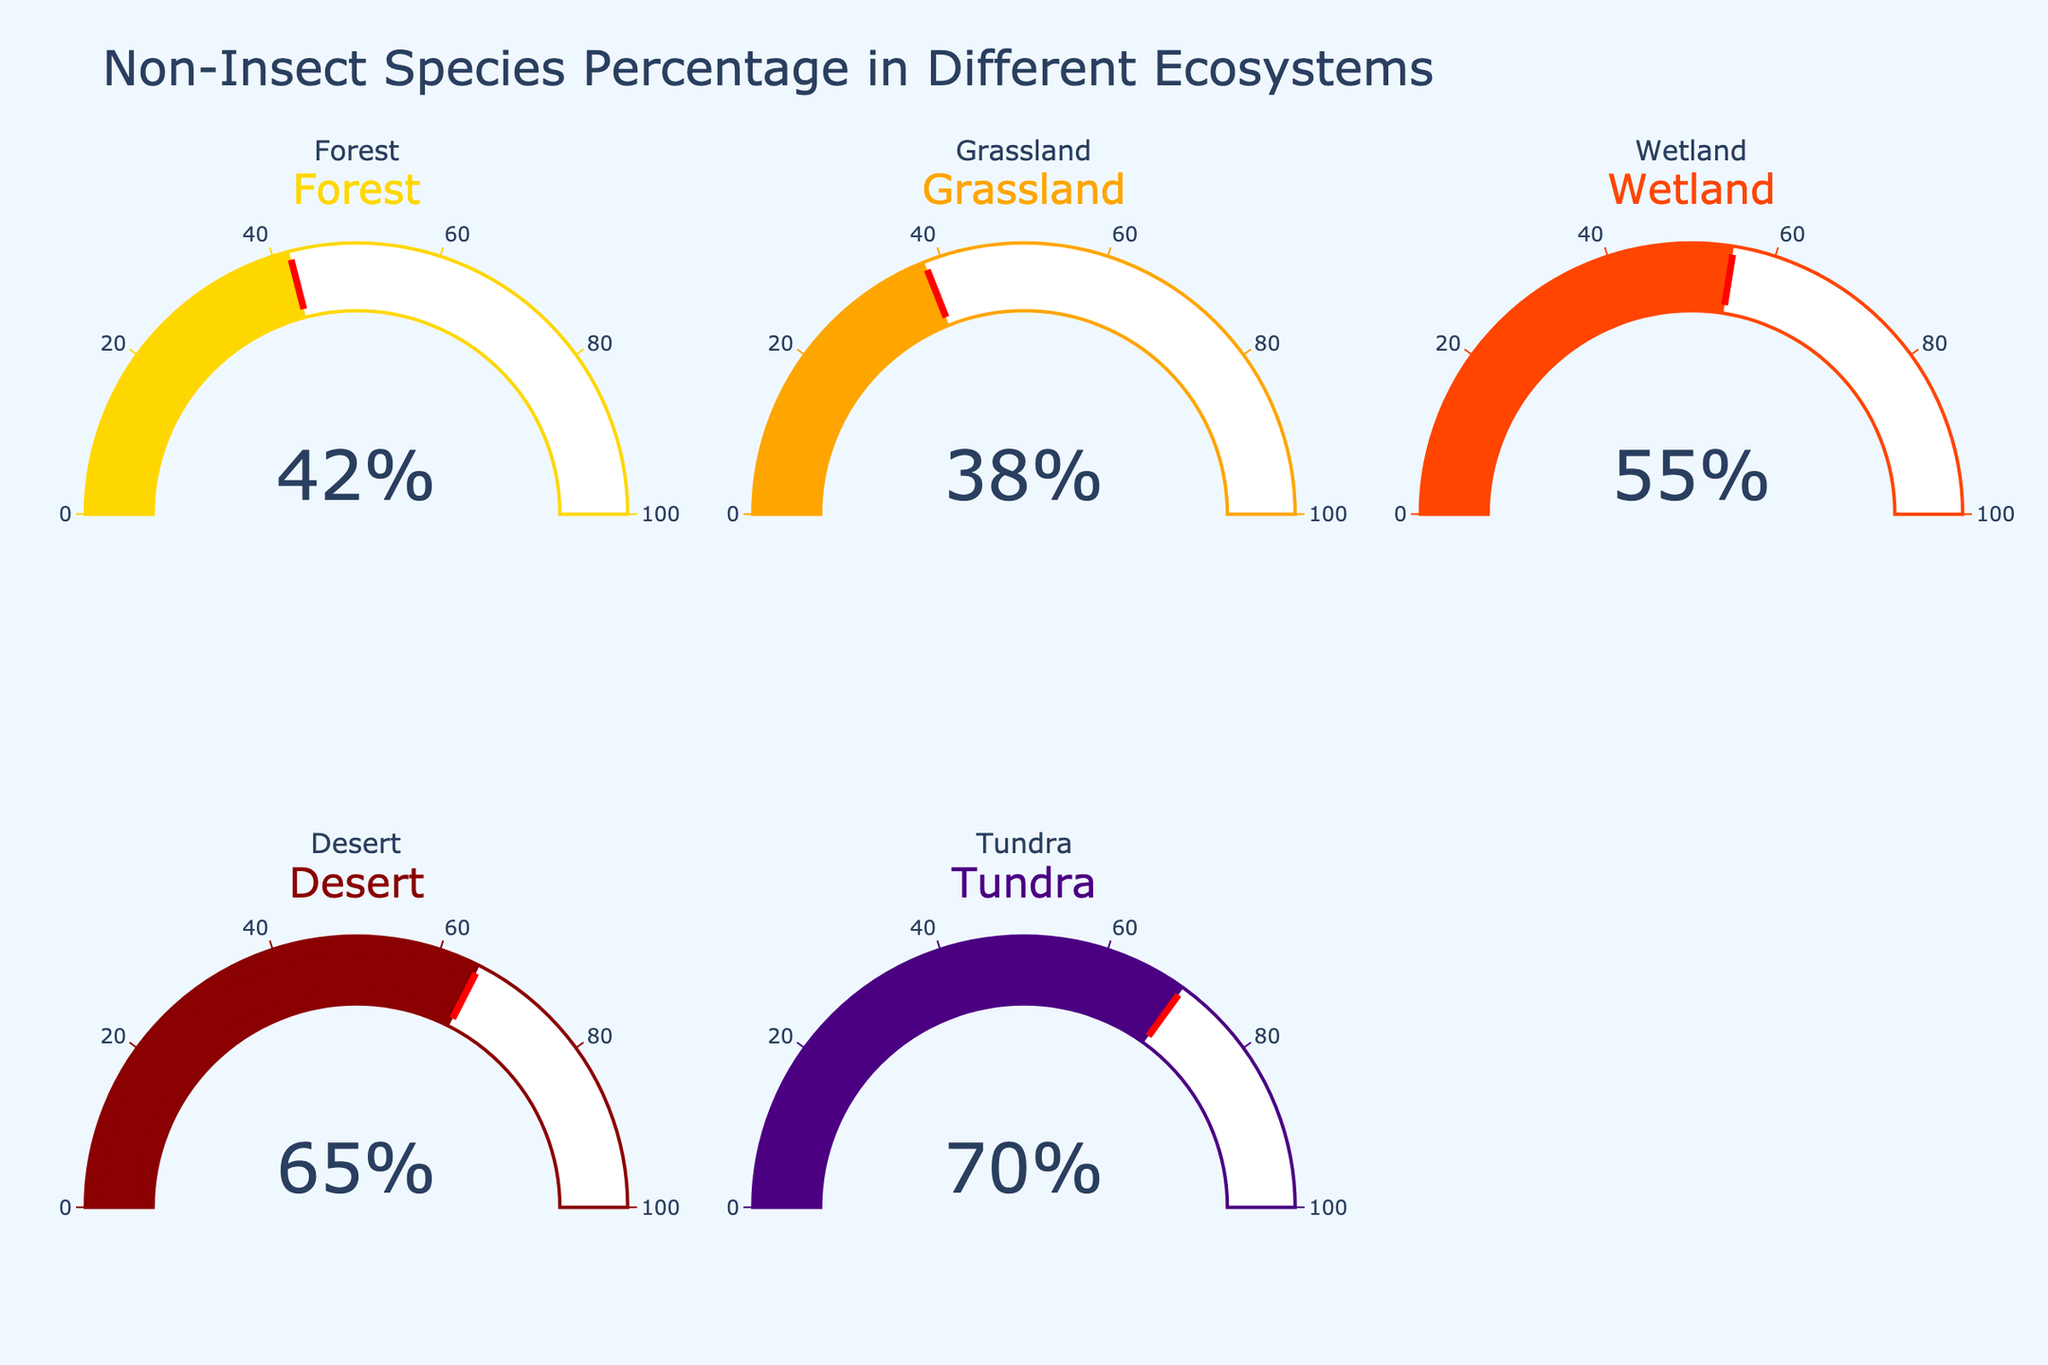Which ecosystem has the highest percentage of non-insect species? Look at the gauge chart values and identify the ecosystem with the highest percentage. The "Tundra" has 70%, which is the highest among all ecosystems.
Answer: Tundra What is the percentage of non-insect species in the Grassland ecosystem? Identify the gauge chart labeled "Grassland" and read the percentage value, which indicates 38%.
Answer: 38% How many ecosystems are displayed in total in the figure? Count all the gauge charts displayed in the figure while noting that there are 5 ecosystems represented (Forest, Grassland, Wetland, Desert, and Tundra).
Answer: 5 Which ecosystem has a lower percentage of non-insect species, Forest or Wetland? Compare the percentage values on the gauge charts for "Forest" and "Wetland." Forest has 42%, and Wetland has 55%. Therefore, Forest has a lower percentage.
Answer: Forest What is the difference between the highest and lowest percentage of non-insect species among the ecosystems? Identify the highest percentage (70% in Tundra) and the lowest percentage (38% in Grassland). Subtract the lowest value from the highest value: 70 - 38 = 32%.
Answer: 32% What's the combined percentage of non-insect species for Desert and Tundra? Look at the gauge charts for "Desert" (65%) and "Tundra" (70%). Add these percentages: 65 + 70 = 135%.
Answer: 135% Which ecosystem has a percentage of non-insect species closest to the average percentage of all ecosystems? Calculate the average percentage: (42 + 38 + 55 + 65 + 70) / 5 = 54%. Then, compare each ecosystem's percentage to the average and find the closest one, which is "Wetland" at 55%.
Answer: Wetland By how much does the percentage of non-insect species in the Wetland ecosystem exceed that in Grassland? Subtract the percentage value of the Grassland (38%) from the Wetland (55%): 55 - 38 = 17%.
Answer: 17% Are there any ecosystems with a percentage of non-insect species below 40%? Look at all gauge charts and identify if any have a percentage below 40%. The "Grassland" with 38% is below 40%.
Answer: Yes What is the median percentage of non-insect species across the five ecosystems? First, list the percentages in ascending order: 38, 42, 55, 65, 70. The median is the middle value, which is 55%.
Answer: 55% 